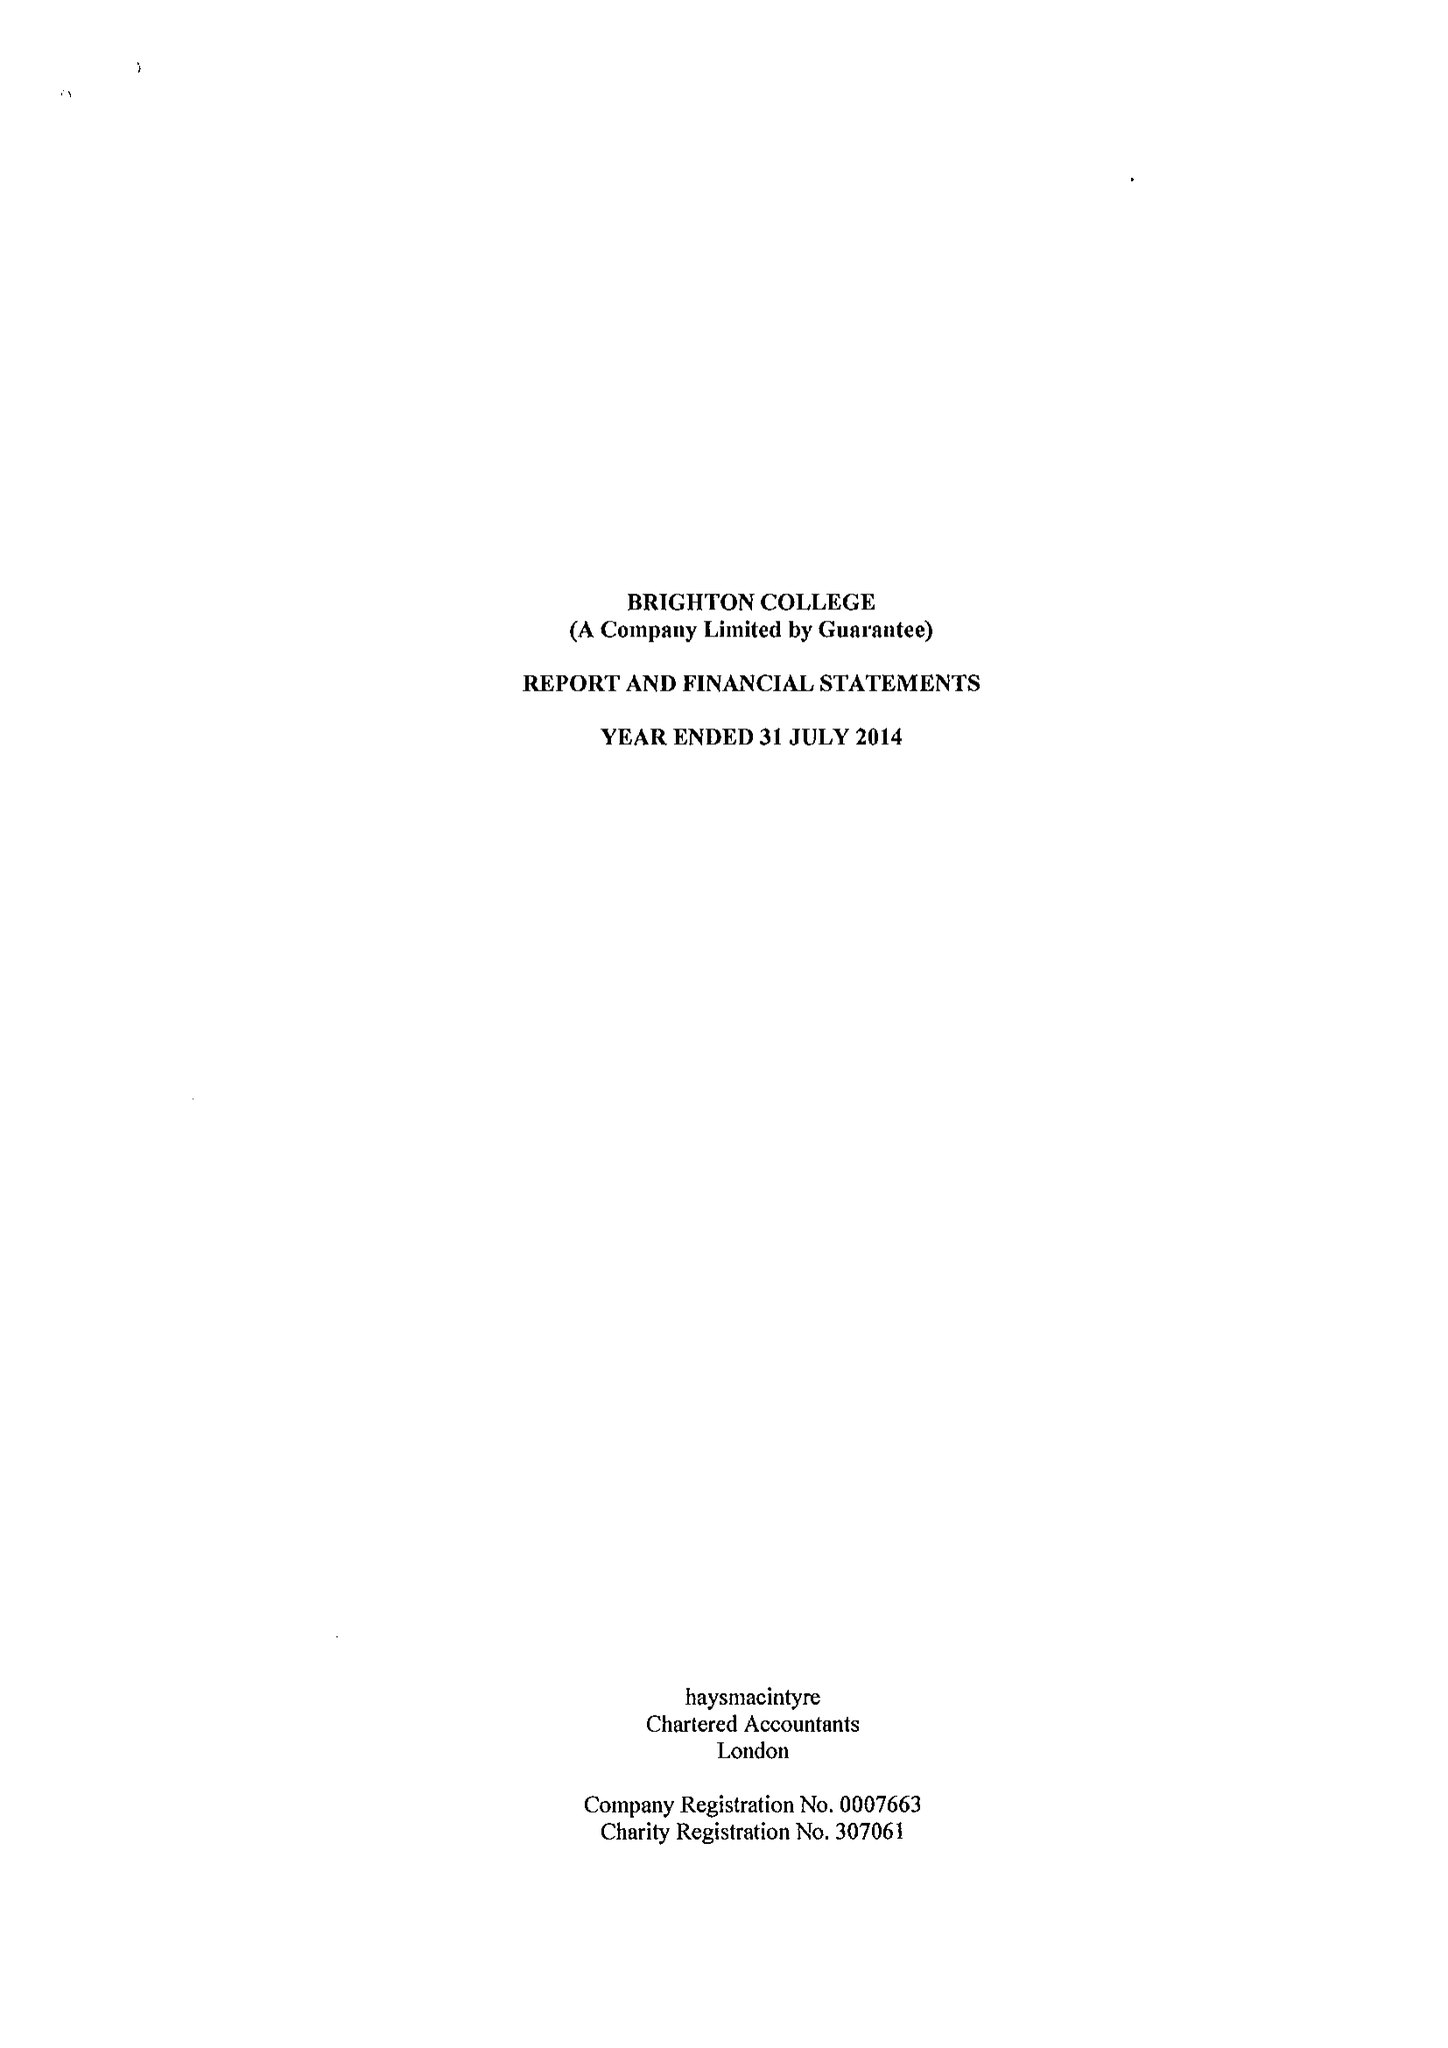What is the value for the address__street_line?
Answer the question using a single word or phrase. EASTERN ROAD 